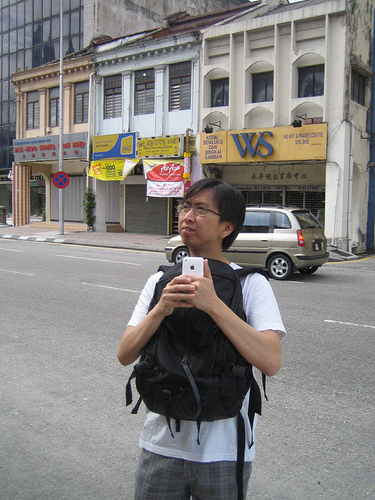<image>
Is the building behind the man? Yes. From this viewpoint, the building is positioned behind the man, with the man partially or fully occluding the building. 